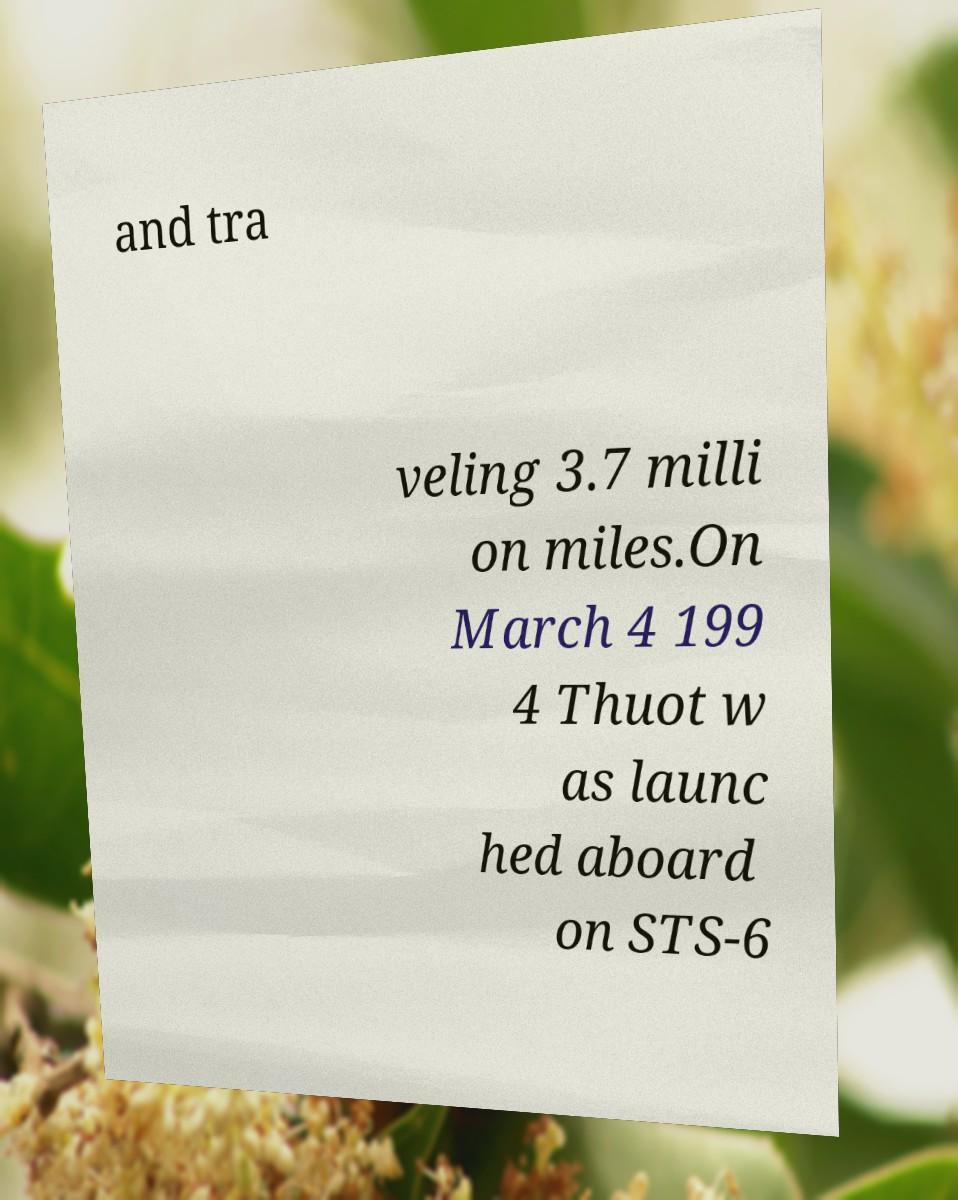Please identify and transcribe the text found in this image. and tra veling 3.7 milli on miles.On March 4 199 4 Thuot w as launc hed aboard on STS-6 